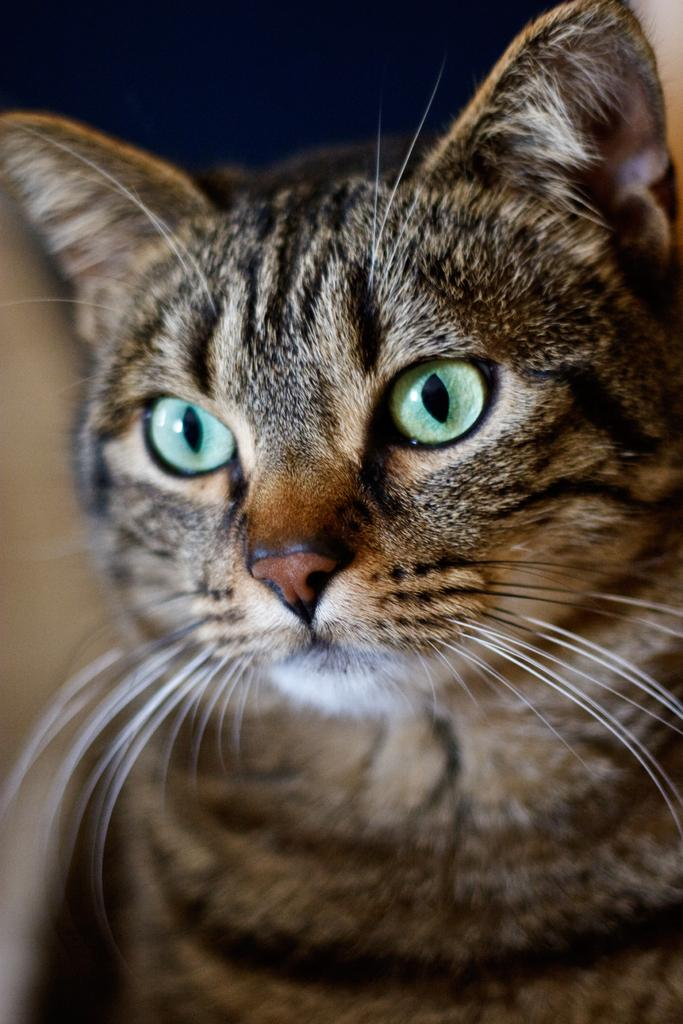What type of animal is in the image? There is a cat in the image. What color is the cat? The cat is brown in color. Can you describe the background of the image? The background of the image is blurred. What type of card is the cat holding in the image? There is no card present in the image; it only features a brown cat with a blurred background. 